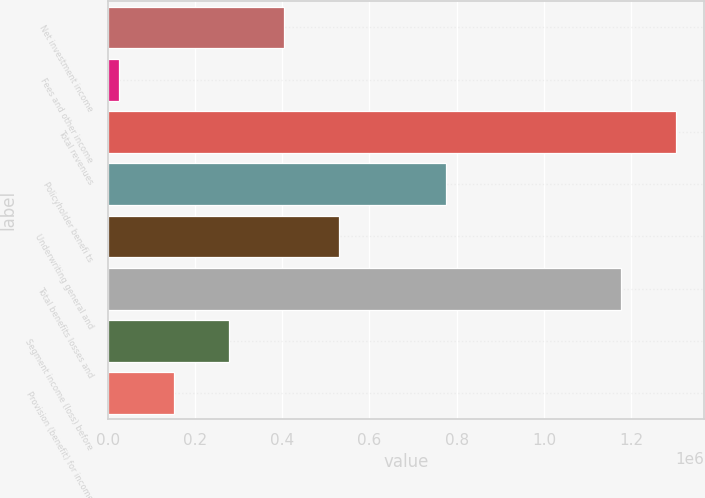Convert chart to OTSL. <chart><loc_0><loc_0><loc_500><loc_500><bar_chart><fcel>Net investment income<fcel>Fees and other income<fcel>Total revenues<fcel>Policyholder benefi ts<fcel>Underwriting general and<fcel>Total benefits losses and<fcel>Segment income (loss) before<fcel>Provision (benefit) for income<nl><fcel>403772<fcel>26139<fcel>1.30238e+06<fcel>775684<fcel>529649<fcel>1.1765e+06<fcel>277894<fcel>152016<nl></chart> 